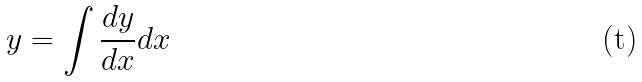Convert formula to latex. <formula><loc_0><loc_0><loc_500><loc_500>y = \int \frac { d y } { d x } d x</formula> 